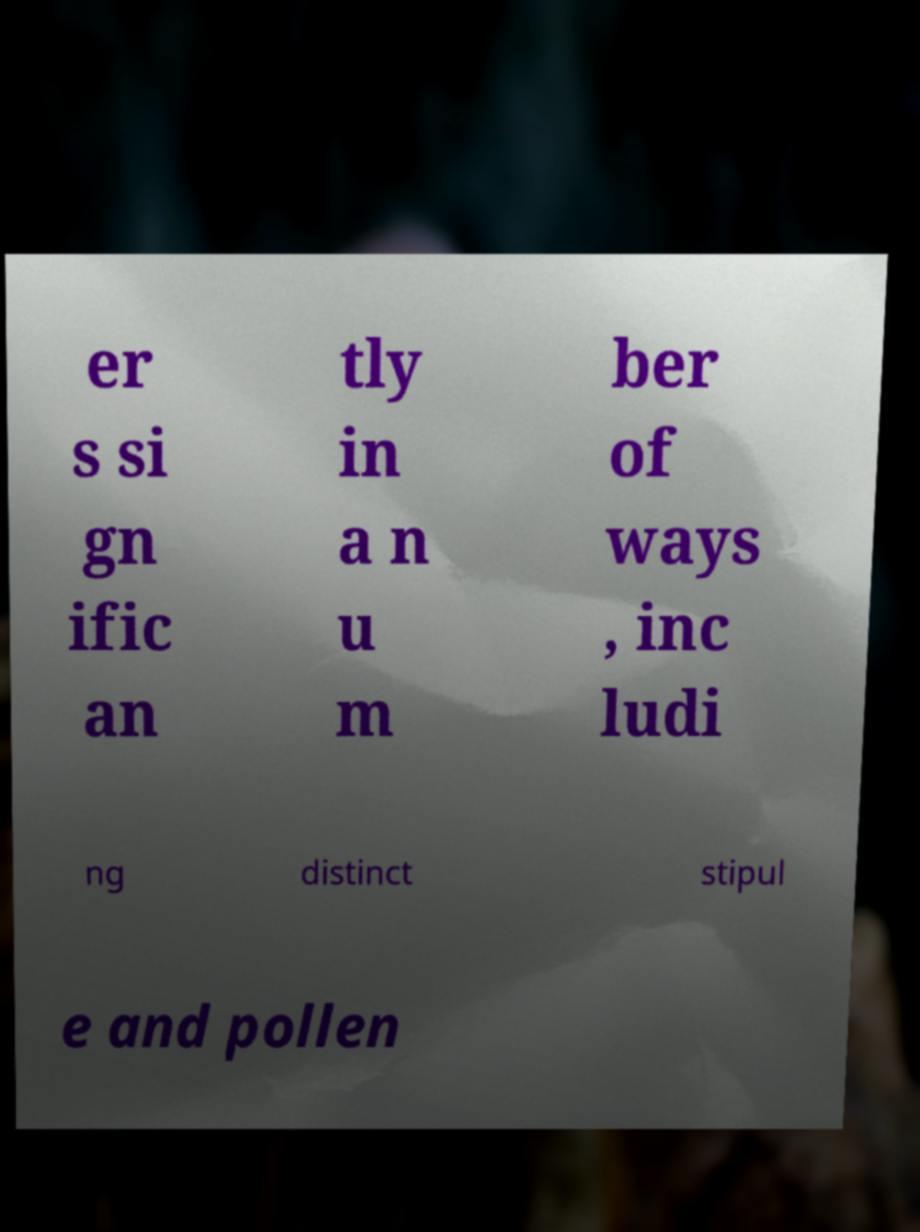I need the written content from this picture converted into text. Can you do that? er s si gn ific an tly in a n u m ber of ways , inc ludi ng distinct stipul e and pollen 